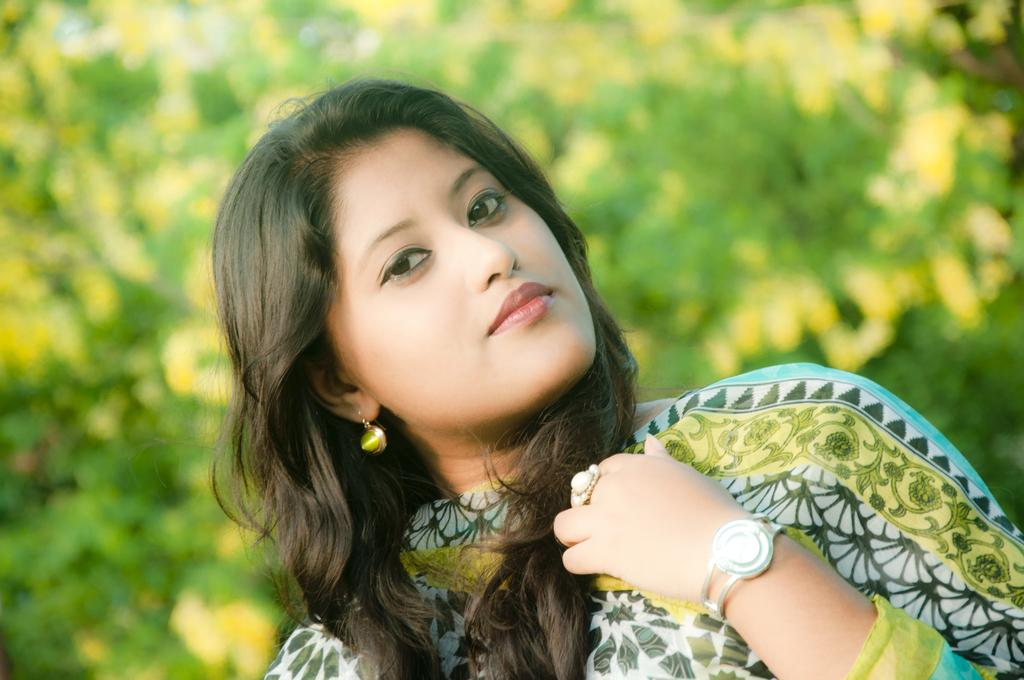Who is present in the image? There is a woman in the image. What accessories is the woman wearing? The woman is wearing a watch on her hand, a ring on her finger, and an earring on her ear. What can be seen in the background of the image? There is a tree in the background of the image. How much coal is being transported by the woman in the image? There is no coal present in the image, and the woman is not transporting anything. 